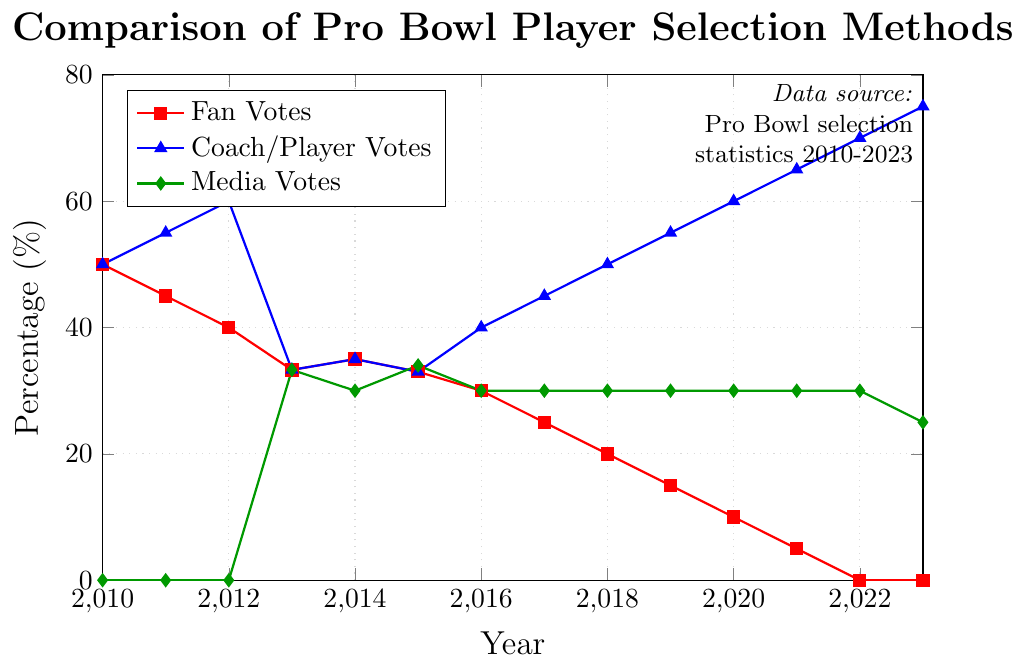Which year did the Fan Votes completely drop out from the Pro Bowl player selection method? The Fan Votes line hits 0% in 2022, indicating its complete removal from the selection method.
Answer: 2022 In what year did Coach/Player Votes first surpass 50%? The plot shows that Coach/Player Votes first exceeded 50% in the year 2018, where it reached 50%.
Answer: 2018 What is the difference in percentage between Coach/Player Votes and Media Votes in 2020? In 2020, Coach/Player Votes are at 60%, and Media Votes are at 30%. The difference is calculated as 60% - 30% = 30%.
Answer: 30% How did the percentage of Fan Votes change between 2015 and 2020? The percentage of Fan Votes in 2015 is 33%, and by 2020, it drops to 10%. The change is calculated as 33% - 10% = 23% decrease.
Answer: 23% decrease Which selection method had the highest percentage in 2013? In 2013, all three selection methods—Fan Votes, Coach/Player Votes, and Media Votes—are at 33.3%, so none had the highest percentage.
Answer: All equal What is the average percentage of Media Votes from 2014 to 2019? The percentages for Media Votes from 2014 to 2019 are 30%, 34%, 30%, 30%, 30%, and 30%. The average is calculated as (30 + 34 + 30 + 30 + 30 + 30) / 6 ≈ 30.67%.
Answer: 30.67% What is the trend in Coach/Player Votes from 2010 to 2023? Coach/Player Votes start at 50% in 2010 and increase consistently to 75% by 2023, showing a clear upward trend over the years.
Answer: Upward trend How much did the Media Votes percentage drop between 2022 and 2023? The Media Votes percentage is 30% in 2022 and drops to 25% in 2023. The decrease is calculated as 30% - 25% = 5%.
Answer: 5% In which year did Fan Votes and Coach/Player Votes have the same percentage for the first time? Fan Votes and Coach/Player Votes both had the same percentage in 2013, where each was at 33.3%.
Answer: 2013 How many years did Media Votes remain stable at 30%? Media Votes remained stable at 30% from 2014 to 2022, which is a total of 9 years.
Answer: 9 years 